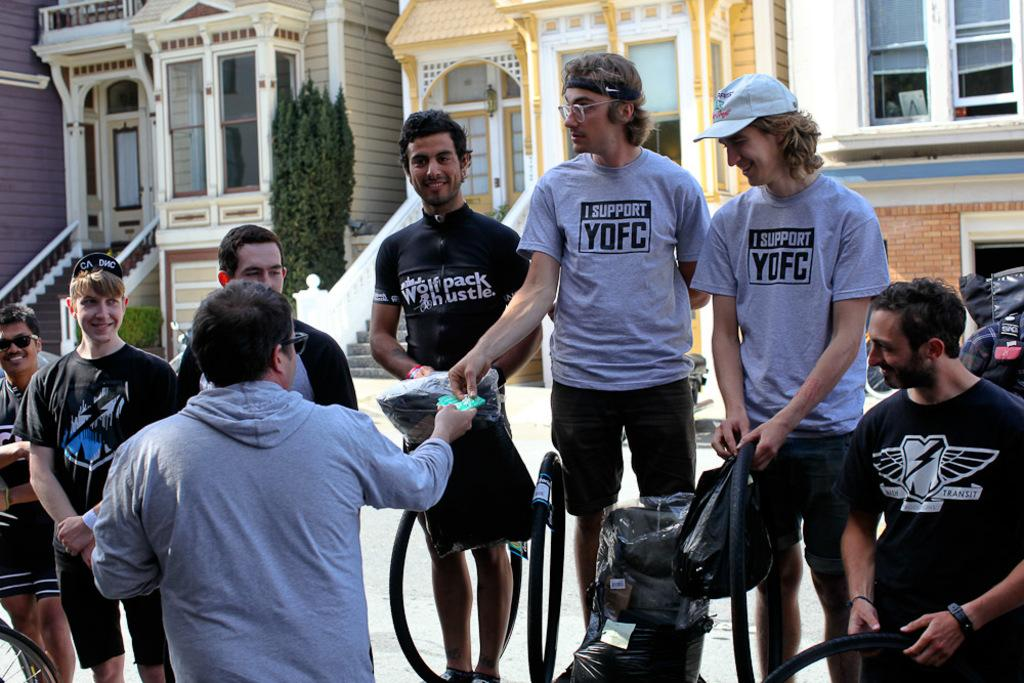How many people are in the image? There are persons in the image, but the exact number is not specified. What are the persons wearing? The persons are wearing clothes. What can be seen in the background of the image? There are buildings in the background of the image. What type of kettle is being used for magic tricks in the image? There is no kettle or magic tricks present in the image. How many cattle are visible in the image? There is no mention of cattle in the image, so it is not possible to determine their presence or number. 